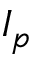Convert formula to latex. <formula><loc_0><loc_0><loc_500><loc_500>I _ { p }</formula> 